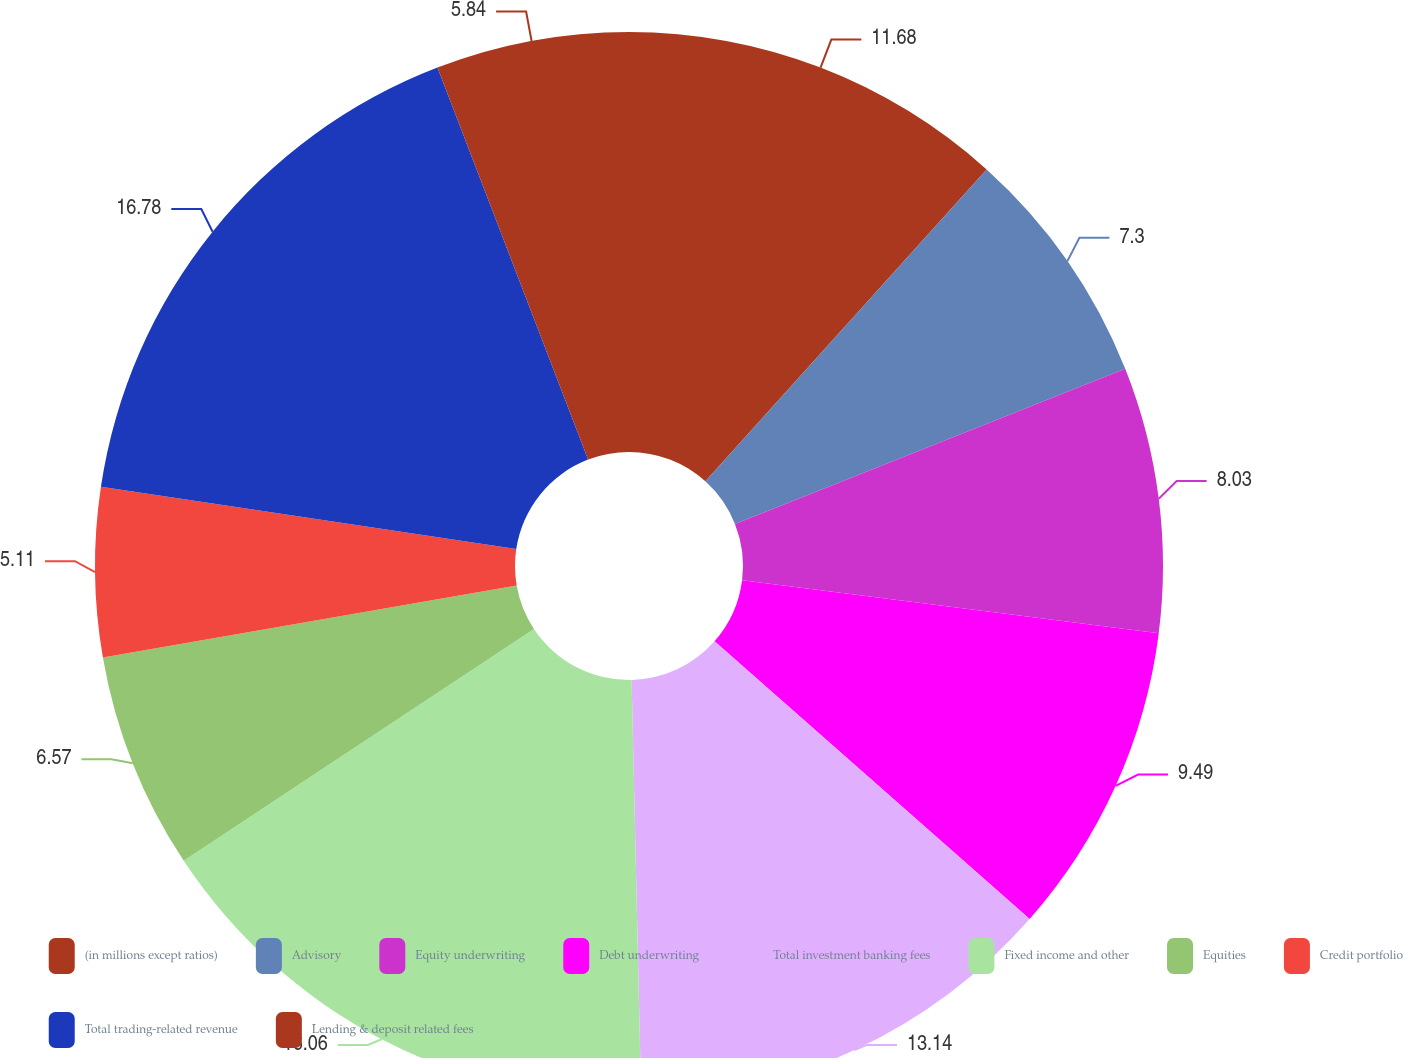Convert chart to OTSL. <chart><loc_0><loc_0><loc_500><loc_500><pie_chart><fcel>(in millions except ratios)<fcel>Advisory<fcel>Equity underwriting<fcel>Debt underwriting<fcel>Total investment banking fees<fcel>Fixed income and other<fcel>Equities<fcel>Credit portfolio<fcel>Total trading-related revenue<fcel>Lending & deposit related fees<nl><fcel>11.68%<fcel>7.3%<fcel>8.03%<fcel>9.49%<fcel>13.14%<fcel>16.06%<fcel>6.57%<fcel>5.11%<fcel>16.79%<fcel>5.84%<nl></chart> 